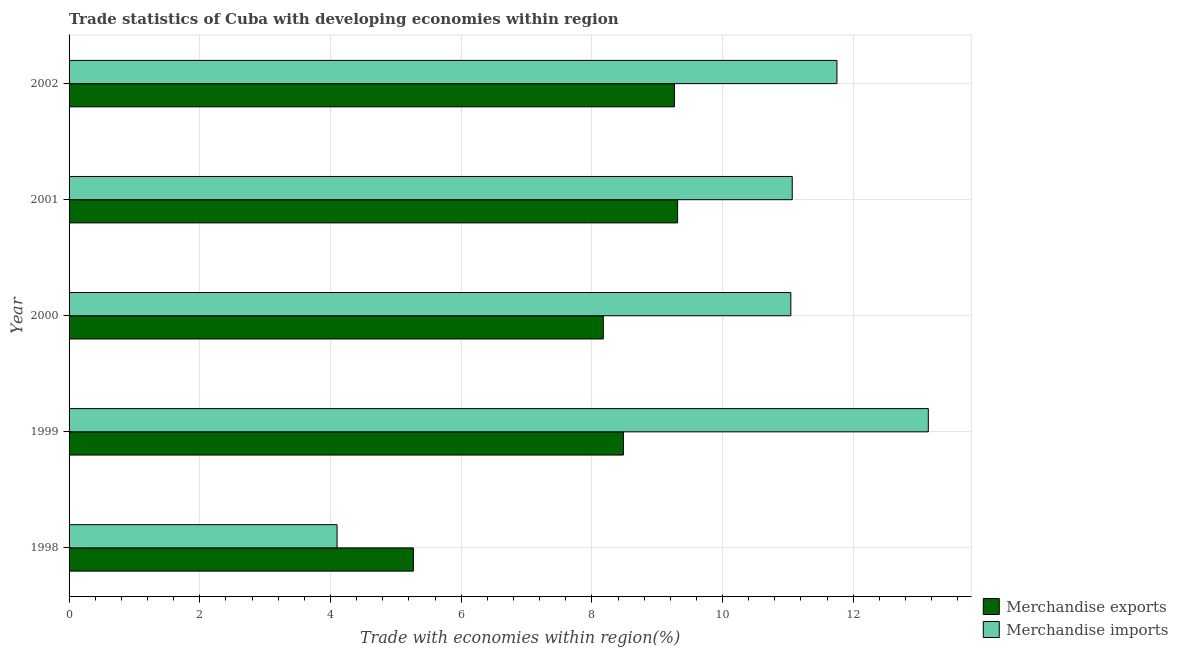How many different coloured bars are there?
Your answer should be compact. 2. Are the number of bars per tick equal to the number of legend labels?
Offer a very short reply. Yes. Are the number of bars on each tick of the Y-axis equal?
Ensure brevity in your answer.  Yes. In how many cases, is the number of bars for a given year not equal to the number of legend labels?
Your response must be concise. 0. What is the merchandise exports in 1999?
Offer a terse response. 8.48. Across all years, what is the maximum merchandise exports?
Make the answer very short. 9.31. Across all years, what is the minimum merchandise imports?
Keep it short and to the point. 4.1. What is the total merchandise exports in the graph?
Keep it short and to the point. 40.5. What is the difference between the merchandise exports in 2000 and that in 2002?
Offer a very short reply. -1.09. What is the difference between the merchandise exports in 1998 and the merchandise imports in 2001?
Your answer should be compact. -5.8. What is the average merchandise imports per year?
Your answer should be very brief. 10.22. In the year 1999, what is the difference between the merchandise exports and merchandise imports?
Provide a succinct answer. -4.67. What is the ratio of the merchandise exports in 2000 to that in 2002?
Your answer should be very brief. 0.88. What is the difference between the highest and the second highest merchandise exports?
Provide a succinct answer. 0.05. What is the difference between the highest and the lowest merchandise exports?
Offer a very short reply. 4.04. In how many years, is the merchandise exports greater than the average merchandise exports taken over all years?
Offer a terse response. 4. Is the sum of the merchandise imports in 1999 and 2001 greater than the maximum merchandise exports across all years?
Your answer should be very brief. Yes. What does the 1st bar from the top in 1998 represents?
Ensure brevity in your answer.  Merchandise imports. How many bars are there?
Your answer should be compact. 10. How many years are there in the graph?
Your answer should be compact. 5. What is the difference between two consecutive major ticks on the X-axis?
Provide a succinct answer. 2. Does the graph contain any zero values?
Make the answer very short. No. Does the graph contain grids?
Offer a very short reply. Yes. Where does the legend appear in the graph?
Provide a succinct answer. Bottom right. What is the title of the graph?
Your response must be concise. Trade statistics of Cuba with developing economies within region. Does "Crop" appear as one of the legend labels in the graph?
Offer a very short reply. No. What is the label or title of the X-axis?
Keep it short and to the point. Trade with economies within region(%). What is the Trade with economies within region(%) of Merchandise exports in 1998?
Ensure brevity in your answer.  5.27. What is the Trade with economies within region(%) in Merchandise imports in 1998?
Ensure brevity in your answer.  4.1. What is the Trade with economies within region(%) in Merchandise exports in 1999?
Your answer should be very brief. 8.48. What is the Trade with economies within region(%) of Merchandise imports in 1999?
Your answer should be compact. 13.15. What is the Trade with economies within region(%) in Merchandise exports in 2000?
Give a very brief answer. 8.18. What is the Trade with economies within region(%) in Merchandise imports in 2000?
Ensure brevity in your answer.  11.05. What is the Trade with economies within region(%) of Merchandise exports in 2001?
Keep it short and to the point. 9.31. What is the Trade with economies within region(%) in Merchandise imports in 2001?
Ensure brevity in your answer.  11.07. What is the Trade with economies within region(%) in Merchandise exports in 2002?
Provide a succinct answer. 9.26. What is the Trade with economies within region(%) in Merchandise imports in 2002?
Your answer should be compact. 11.75. Across all years, what is the maximum Trade with economies within region(%) in Merchandise exports?
Provide a short and direct response. 9.31. Across all years, what is the maximum Trade with economies within region(%) of Merchandise imports?
Give a very brief answer. 13.15. Across all years, what is the minimum Trade with economies within region(%) in Merchandise exports?
Provide a succinct answer. 5.27. Across all years, what is the minimum Trade with economies within region(%) of Merchandise imports?
Offer a very short reply. 4.1. What is the total Trade with economies within region(%) in Merchandise exports in the graph?
Provide a short and direct response. 40.5. What is the total Trade with economies within region(%) of Merchandise imports in the graph?
Your answer should be very brief. 51.11. What is the difference between the Trade with economies within region(%) in Merchandise exports in 1998 and that in 1999?
Keep it short and to the point. -3.21. What is the difference between the Trade with economies within region(%) in Merchandise imports in 1998 and that in 1999?
Your response must be concise. -9.05. What is the difference between the Trade with economies within region(%) of Merchandise exports in 1998 and that in 2000?
Make the answer very short. -2.91. What is the difference between the Trade with economies within region(%) in Merchandise imports in 1998 and that in 2000?
Provide a short and direct response. -6.94. What is the difference between the Trade with economies within region(%) of Merchandise exports in 1998 and that in 2001?
Provide a short and direct response. -4.04. What is the difference between the Trade with economies within region(%) in Merchandise imports in 1998 and that in 2001?
Make the answer very short. -6.97. What is the difference between the Trade with economies within region(%) in Merchandise exports in 1998 and that in 2002?
Provide a short and direct response. -4. What is the difference between the Trade with economies within region(%) in Merchandise imports in 1998 and that in 2002?
Offer a terse response. -7.65. What is the difference between the Trade with economies within region(%) of Merchandise exports in 1999 and that in 2000?
Offer a very short reply. 0.31. What is the difference between the Trade with economies within region(%) in Merchandise imports in 1999 and that in 2000?
Keep it short and to the point. 2.1. What is the difference between the Trade with economies within region(%) of Merchandise exports in 1999 and that in 2001?
Ensure brevity in your answer.  -0.83. What is the difference between the Trade with economies within region(%) of Merchandise imports in 1999 and that in 2001?
Provide a short and direct response. 2.08. What is the difference between the Trade with economies within region(%) in Merchandise exports in 1999 and that in 2002?
Your answer should be very brief. -0.78. What is the difference between the Trade with economies within region(%) in Merchandise imports in 1999 and that in 2002?
Your answer should be compact. 1.4. What is the difference between the Trade with economies within region(%) in Merchandise exports in 2000 and that in 2001?
Offer a very short reply. -1.14. What is the difference between the Trade with economies within region(%) in Merchandise imports in 2000 and that in 2001?
Your response must be concise. -0.02. What is the difference between the Trade with economies within region(%) in Merchandise exports in 2000 and that in 2002?
Give a very brief answer. -1.09. What is the difference between the Trade with economies within region(%) in Merchandise imports in 2000 and that in 2002?
Keep it short and to the point. -0.71. What is the difference between the Trade with economies within region(%) in Merchandise exports in 2001 and that in 2002?
Your answer should be compact. 0.05. What is the difference between the Trade with economies within region(%) in Merchandise imports in 2001 and that in 2002?
Make the answer very short. -0.68. What is the difference between the Trade with economies within region(%) in Merchandise exports in 1998 and the Trade with economies within region(%) in Merchandise imports in 1999?
Offer a terse response. -7.88. What is the difference between the Trade with economies within region(%) of Merchandise exports in 1998 and the Trade with economies within region(%) of Merchandise imports in 2000?
Provide a succinct answer. -5.78. What is the difference between the Trade with economies within region(%) of Merchandise exports in 1998 and the Trade with economies within region(%) of Merchandise imports in 2001?
Offer a terse response. -5.8. What is the difference between the Trade with economies within region(%) of Merchandise exports in 1998 and the Trade with economies within region(%) of Merchandise imports in 2002?
Provide a short and direct response. -6.48. What is the difference between the Trade with economies within region(%) of Merchandise exports in 1999 and the Trade with economies within region(%) of Merchandise imports in 2000?
Keep it short and to the point. -2.56. What is the difference between the Trade with economies within region(%) in Merchandise exports in 1999 and the Trade with economies within region(%) in Merchandise imports in 2001?
Keep it short and to the point. -2.58. What is the difference between the Trade with economies within region(%) of Merchandise exports in 1999 and the Trade with economies within region(%) of Merchandise imports in 2002?
Provide a short and direct response. -3.27. What is the difference between the Trade with economies within region(%) in Merchandise exports in 2000 and the Trade with economies within region(%) in Merchandise imports in 2001?
Make the answer very short. -2.89. What is the difference between the Trade with economies within region(%) in Merchandise exports in 2000 and the Trade with economies within region(%) in Merchandise imports in 2002?
Keep it short and to the point. -3.57. What is the difference between the Trade with economies within region(%) in Merchandise exports in 2001 and the Trade with economies within region(%) in Merchandise imports in 2002?
Make the answer very short. -2.44. What is the average Trade with economies within region(%) in Merchandise exports per year?
Provide a succinct answer. 8.1. What is the average Trade with economies within region(%) of Merchandise imports per year?
Your response must be concise. 10.22. In the year 1998, what is the difference between the Trade with economies within region(%) of Merchandise exports and Trade with economies within region(%) of Merchandise imports?
Your response must be concise. 1.17. In the year 1999, what is the difference between the Trade with economies within region(%) in Merchandise exports and Trade with economies within region(%) in Merchandise imports?
Your response must be concise. -4.67. In the year 2000, what is the difference between the Trade with economies within region(%) of Merchandise exports and Trade with economies within region(%) of Merchandise imports?
Offer a very short reply. -2.87. In the year 2001, what is the difference between the Trade with economies within region(%) of Merchandise exports and Trade with economies within region(%) of Merchandise imports?
Your answer should be compact. -1.75. In the year 2002, what is the difference between the Trade with economies within region(%) in Merchandise exports and Trade with economies within region(%) in Merchandise imports?
Give a very brief answer. -2.49. What is the ratio of the Trade with economies within region(%) in Merchandise exports in 1998 to that in 1999?
Your answer should be very brief. 0.62. What is the ratio of the Trade with economies within region(%) in Merchandise imports in 1998 to that in 1999?
Ensure brevity in your answer.  0.31. What is the ratio of the Trade with economies within region(%) in Merchandise exports in 1998 to that in 2000?
Provide a succinct answer. 0.64. What is the ratio of the Trade with economies within region(%) in Merchandise imports in 1998 to that in 2000?
Your response must be concise. 0.37. What is the ratio of the Trade with economies within region(%) of Merchandise exports in 1998 to that in 2001?
Offer a very short reply. 0.57. What is the ratio of the Trade with economies within region(%) in Merchandise imports in 1998 to that in 2001?
Make the answer very short. 0.37. What is the ratio of the Trade with economies within region(%) in Merchandise exports in 1998 to that in 2002?
Keep it short and to the point. 0.57. What is the ratio of the Trade with economies within region(%) of Merchandise imports in 1998 to that in 2002?
Your answer should be very brief. 0.35. What is the ratio of the Trade with economies within region(%) in Merchandise exports in 1999 to that in 2000?
Ensure brevity in your answer.  1.04. What is the ratio of the Trade with economies within region(%) of Merchandise imports in 1999 to that in 2000?
Offer a very short reply. 1.19. What is the ratio of the Trade with economies within region(%) in Merchandise exports in 1999 to that in 2001?
Your response must be concise. 0.91. What is the ratio of the Trade with economies within region(%) in Merchandise imports in 1999 to that in 2001?
Offer a terse response. 1.19. What is the ratio of the Trade with economies within region(%) of Merchandise exports in 1999 to that in 2002?
Give a very brief answer. 0.92. What is the ratio of the Trade with economies within region(%) of Merchandise imports in 1999 to that in 2002?
Offer a terse response. 1.12. What is the ratio of the Trade with economies within region(%) of Merchandise exports in 2000 to that in 2001?
Offer a terse response. 0.88. What is the ratio of the Trade with economies within region(%) in Merchandise exports in 2000 to that in 2002?
Your response must be concise. 0.88. What is the ratio of the Trade with economies within region(%) in Merchandise exports in 2001 to that in 2002?
Your answer should be compact. 1.01. What is the ratio of the Trade with economies within region(%) in Merchandise imports in 2001 to that in 2002?
Provide a succinct answer. 0.94. What is the difference between the highest and the second highest Trade with economies within region(%) of Merchandise exports?
Your answer should be very brief. 0.05. What is the difference between the highest and the second highest Trade with economies within region(%) in Merchandise imports?
Offer a terse response. 1.4. What is the difference between the highest and the lowest Trade with economies within region(%) in Merchandise exports?
Ensure brevity in your answer.  4.04. What is the difference between the highest and the lowest Trade with economies within region(%) in Merchandise imports?
Your response must be concise. 9.05. 